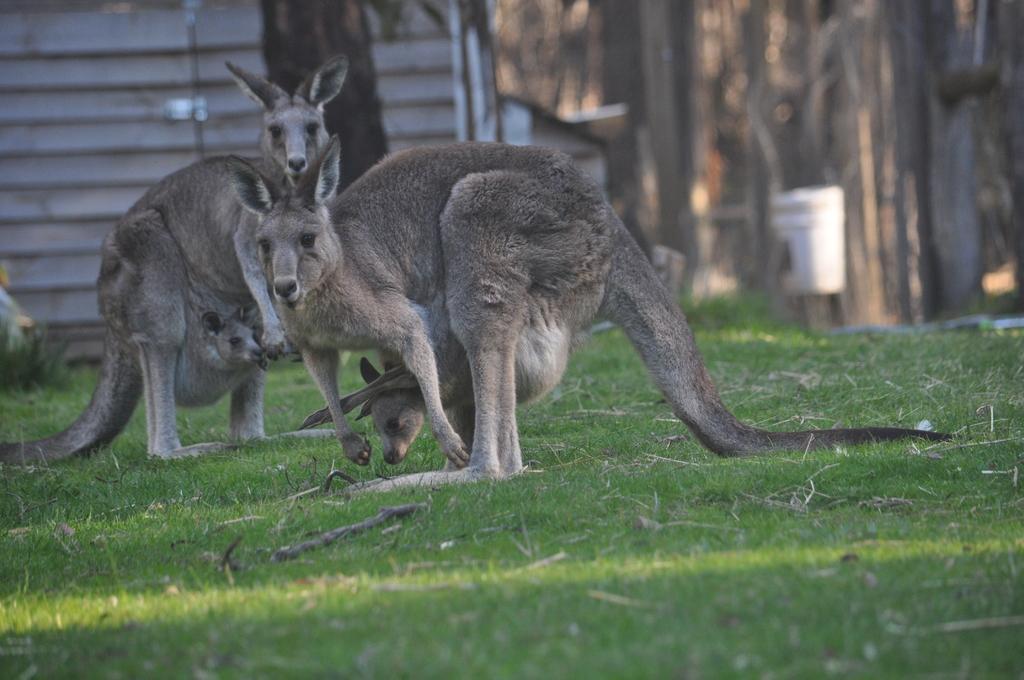Please provide a concise description of this image. In the image there are two kangaroos standing on the grass and there are babies in their pocket and the background is blurry. 